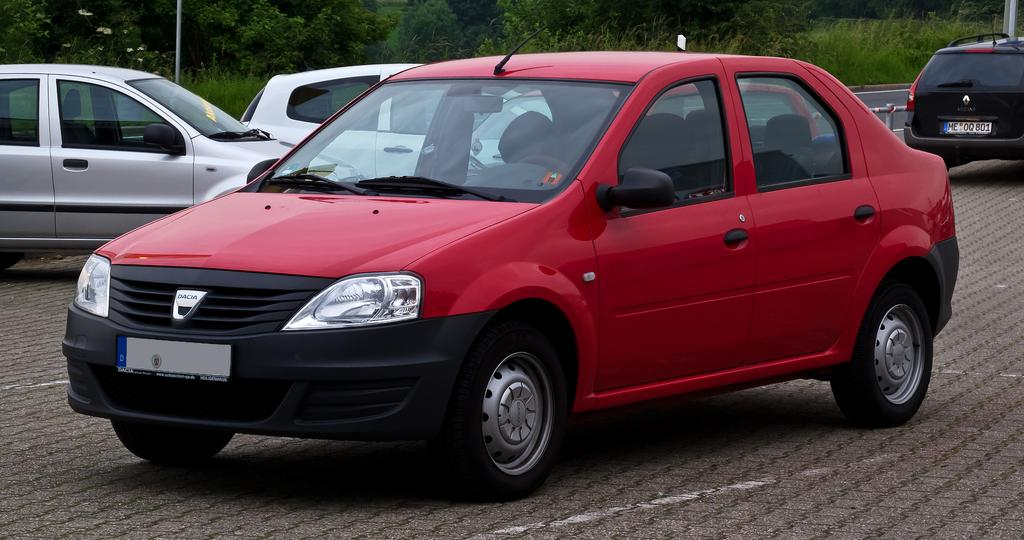What is the main subject in the center of the image? There are cars in the center of the image. What is located at the bottom of the image? There is a road at the bottom of the image. What can be seen in the background of the image? There are trees and poles in the background of the image. Where is the quiet meeting taking place in the image? There is no meeting or quiet location mentioned in the image; it primarily features cars, a road, trees, and poles. Are there any boats visible in the image? No, there are no boats present in the image. 